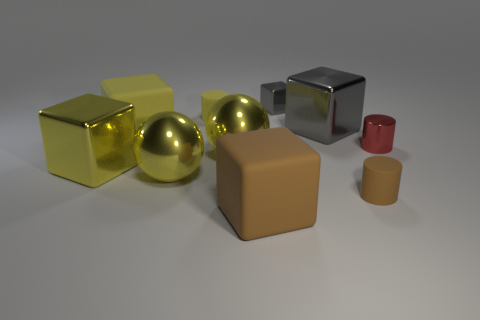Do the brown rubber cylinder and the yellow matte cube have the same size?
Provide a succinct answer. No. How many tiny red cylinders are in front of the yellow block on the left side of the large yellow rubber object?
Your answer should be compact. 0. Is there a brown object of the same shape as the small red object?
Provide a short and direct response. Yes. There is a big shiny cube behind the tiny metallic object that is on the right side of the large gray block; what is its color?
Offer a terse response. Gray. Is the number of yellow cubes greater than the number of tiny gray shiny blocks?
Make the answer very short. Yes. How many rubber things are the same size as the yellow metallic cube?
Ensure brevity in your answer.  2. Is the material of the tiny red thing the same as the brown thing to the left of the large gray metallic thing?
Offer a very short reply. No. Are there fewer balls than small metallic cubes?
Your response must be concise. No. Is there any other thing of the same color as the small block?
Offer a very short reply. Yes. There is a large yellow object that is made of the same material as the small yellow cylinder; what is its shape?
Keep it short and to the point. Cube. 